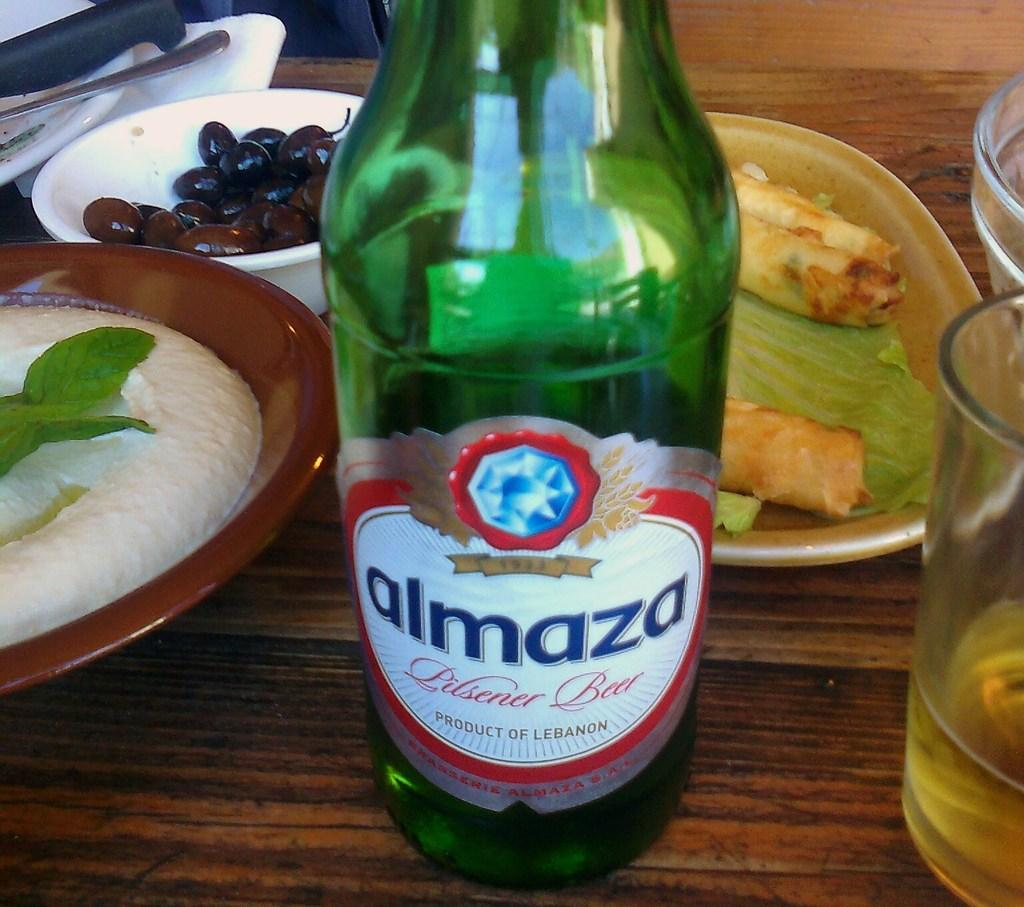<image>
Provide a brief description of the given image. a green bottle of almaza pilsener beer product of lebanon 